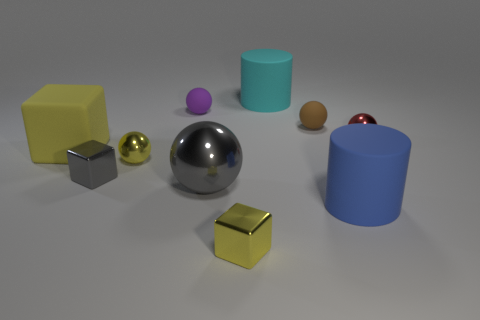There is a yellow rubber object; does it have the same shape as the gray thing on the left side of the small purple object?
Provide a succinct answer. Yes. There is a rubber ball left of the tiny thing in front of the blue rubber cylinder; what number of tiny purple matte spheres are left of it?
Your response must be concise. 0. There is a big metallic thing that is the same shape as the purple matte object; what is its color?
Offer a terse response. Gray. Are there any other things that have the same shape as the small red thing?
Offer a very short reply. Yes. How many cubes are tiny purple rubber things or blue rubber things?
Your answer should be compact. 0. What is the shape of the small brown matte thing?
Ensure brevity in your answer.  Sphere. There is a tiny yellow block; are there any cylinders in front of it?
Your answer should be very brief. No. Are the gray sphere and the tiny cube on the right side of the big gray sphere made of the same material?
Your response must be concise. Yes. There is a rubber thing that is to the right of the brown rubber ball; is its shape the same as the small red thing?
Give a very brief answer. No. What number of other tiny objects are made of the same material as the red object?
Offer a very short reply. 3. 